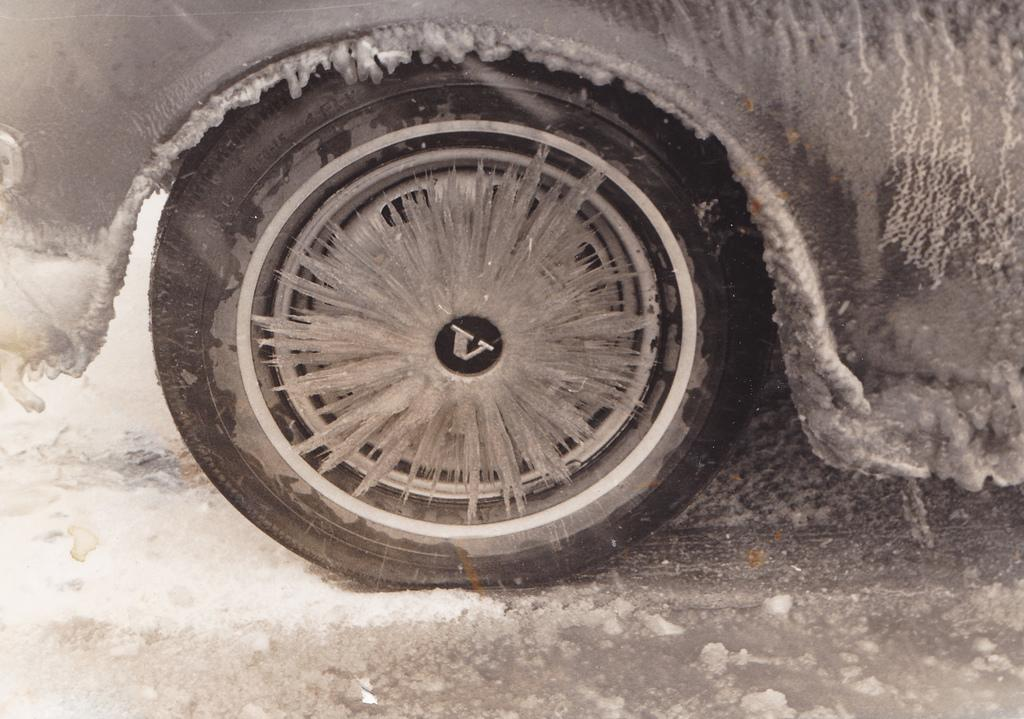What is the main subject of the image? A: There is a vehicle in the image. Where is the vehicle located? The vehicle is on the road. What is the color scheme of the image? The image is in black and white. How many horses are visible in the image? There are no horses present in the image. What type of mist can be seen surrounding the vehicle in the image? There is no mist present in the image; it is in black and white. 